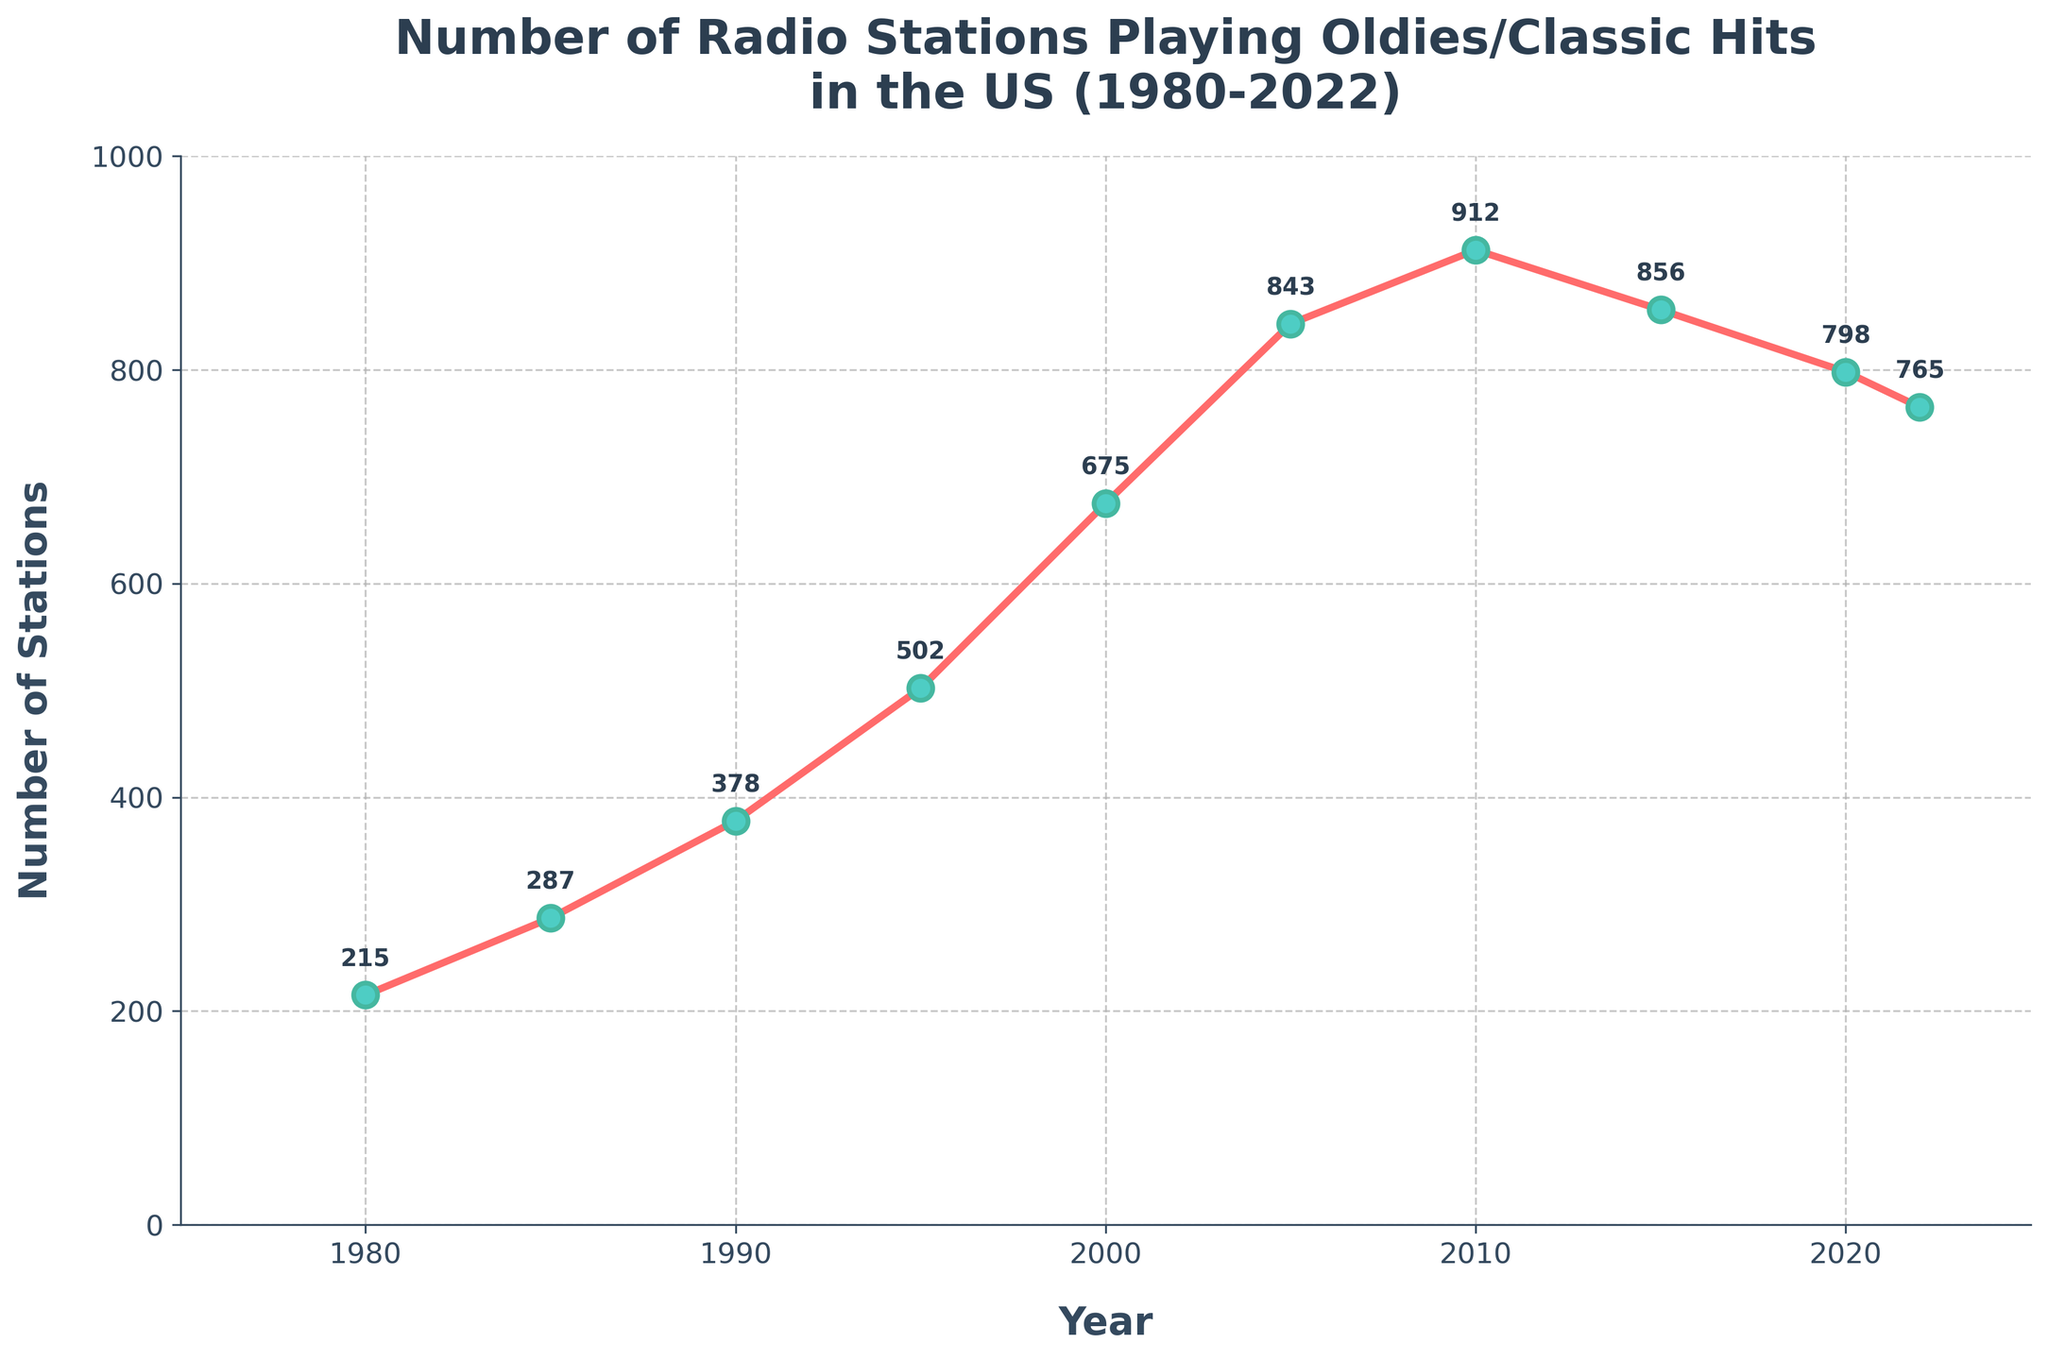What was the overall trend in the number of radio stations playing oldies/classic hits from 1980 to 2022? The overall trend shows a significant rise from 1980 to 2010, followed by a gradual decline from 2010 to 2022.
Answer: Rising until 2010, then declining Which year had the highest number of radio stations playing oldies/classic hits? The highest point on the line chart appears around 2010, where the number of stations peaks at 912.
Answer: 2010 How many radio stations were playing oldies/classic hits in 1995, and how does this compare to 1980? In 1995, there were 502 stations, while in 1980 there were 215. By subtracting, 502 - 215 = 287, indicating that there were 287 more stations in 1995 compared to 1980.
Answer: 287 more What is the difference in the number of stations between 2010 and 2022? In 2010, there were 912 stations, and in 2022, there were 765 stations. The difference is 912 - 765 = 147.
Answer: 147 In which decade did the number of radio stations increase the most? The increase is evaluated by inspecting the increments between points on the line chart. From 1990 to 2000, the number of stations went from 378 to 675, which is an increase of 297, the largest among the intervals.
Answer: 1990-2000 How does the number of radio stations in 2022 compare to the number in 2000? In 2000, there were 675 stations, and in 2022 there were 765 stations. The number in 2022 is greater by 765 - 675 = 90.
Answer: 90 more What can you infer about the trend in the number of radio stations from 2005 to 2015? The number of stations increased from 843 in 2005 to 912 in 2010 and then decreased to 856 in 2015, indicating a peak in 2010 followed by a decline.
Answer: Peaked in 2010, then declined What is the average number of stations for the years 1980, 1990, 2000, 2010, and 2022? Sum the numbers for these years: 215 (1980) + 378 (1990) + 675 (2000) + 912 (2010) + 765 (2022) = 2945. Divide by 5 to get the average: 2945 / 5 = 589.
Answer: 589 How many years saw an increase in the number of radio stations compared to the previous period? By observing the increase: 1980 to 1985, 1985 to 1990, 1990 to 1995, 1995 to 2000, 2000 to 2005, and 2005 to 2010 all show increases. Therefore, 6 periods saw an increase.
Answer: 6 In which year did the number of stations first exceed 500? By observing the values, the number of stations first exceeded 500 in 1995, with 502 stations.
Answer: 1995 